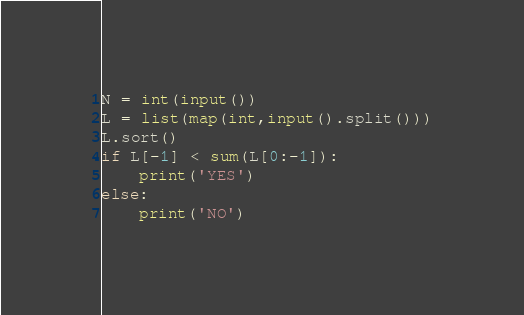<code> <loc_0><loc_0><loc_500><loc_500><_Python_>N = int(input())
L = list(map(int,input().split()))
L.sort()
if L[-1] < sum(L[0:-1]):
    print('YES')
else:
    print('NO')</code> 